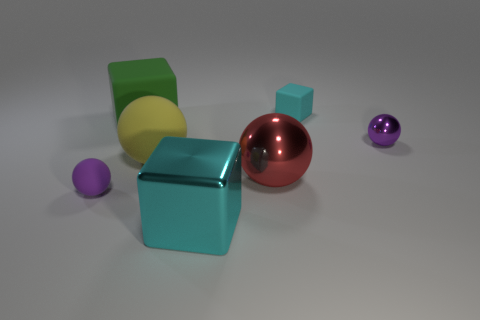Add 1 big cubes. How many objects exist? 8 Subtract all blocks. How many objects are left? 4 Add 1 big red metallic spheres. How many big red metallic spheres exist? 2 Subtract 0 gray blocks. How many objects are left? 7 Subtract all tiny cyan blocks. Subtract all big yellow metal cylinders. How many objects are left? 6 Add 1 large green rubber objects. How many large green rubber objects are left? 2 